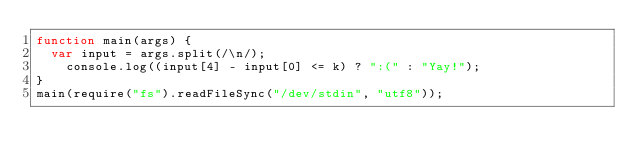<code> <loc_0><loc_0><loc_500><loc_500><_JavaScript_>function main(args) {
	var input = args.split(/\n/);
  	console.log((input[4] - input[0] <= k) ? ":(" : "Yay!");
}
main(require("fs").readFileSync("/dev/stdin", "utf8"));</code> 